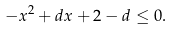Convert formula to latex. <formula><loc_0><loc_0><loc_500><loc_500>- x ^ { 2 } + d x + 2 - d & \leq 0 .</formula> 